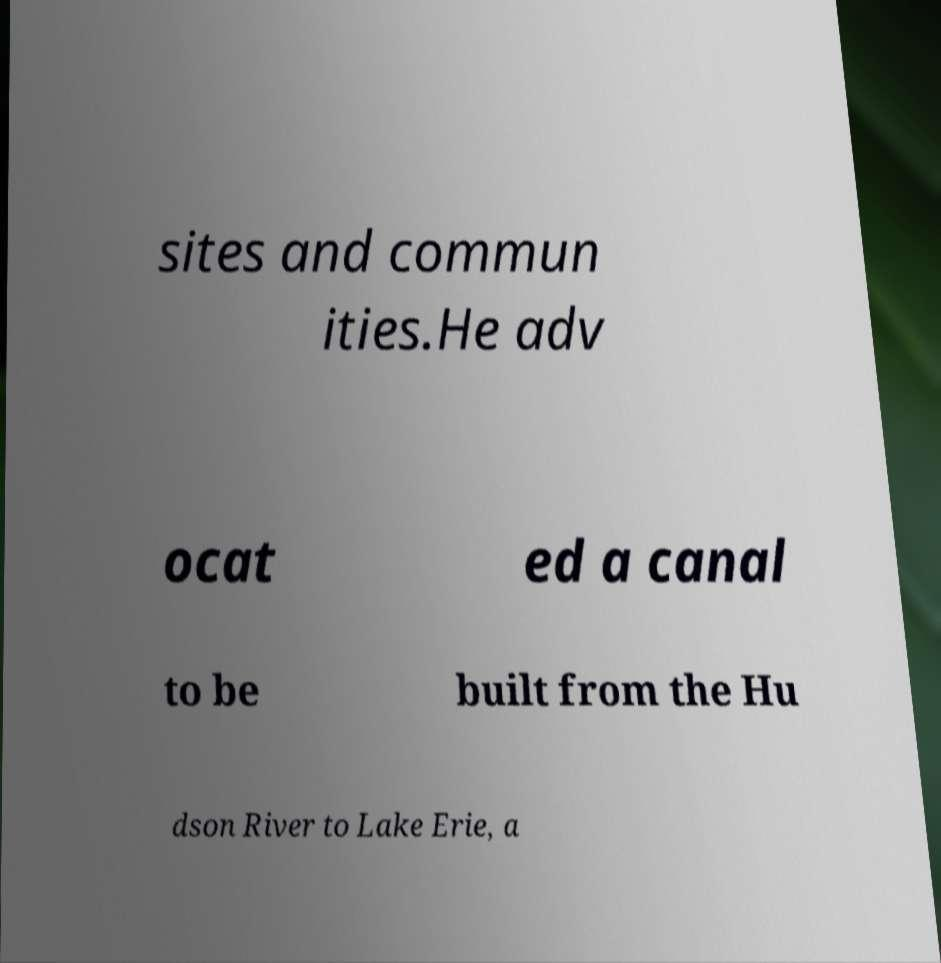Can you read and provide the text displayed in the image?This photo seems to have some interesting text. Can you extract and type it out for me? sites and commun ities.He adv ocat ed a canal to be built from the Hu dson River to Lake Erie, a 